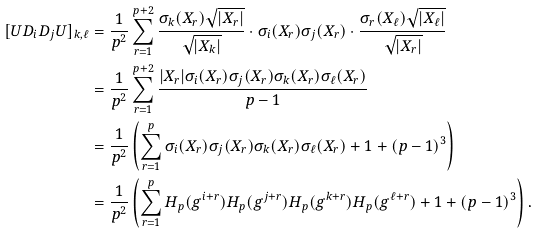Convert formula to latex. <formula><loc_0><loc_0><loc_500><loc_500>[ U D _ { i } D _ { j } U ] _ { k , \ell } & = \frac { 1 } { p ^ { 2 } } \sum _ { r = 1 } ^ { p + 2 } \frac { \sigma _ { k } ( X _ { r } ) \sqrt { | X _ { r } | } } { \sqrt { | X _ { k } | } } \cdot \sigma _ { i } ( X _ { r } ) \sigma _ { j } ( X _ { r } ) \cdot \frac { \sigma _ { r } ( X _ { \ell } ) \sqrt { | X _ { \ell } | } } { \sqrt { | X _ { r } | } } \\ & = \frac { 1 } { p ^ { 2 } } \sum _ { r = 1 } ^ { p + 2 } \frac { | X _ { r } | \sigma _ { i } ( X _ { r } ) \sigma _ { j } ( X _ { r } ) \sigma _ { k } ( X _ { r } ) \sigma _ { \ell } ( X _ { r } ) } { p - 1 } \\ & = \frac { 1 } { p ^ { 2 } } \left ( \sum _ { r = 1 } ^ { p } \sigma _ { i } ( X _ { r } ) \sigma _ { j } ( X _ { r } ) \sigma _ { k } ( X _ { r } ) \sigma _ { \ell } ( X _ { r } ) + 1 + ( p - 1 ) ^ { 3 } \right ) \\ & = \frac { 1 } { p ^ { 2 } } \left ( \sum _ { r = 1 } ^ { p } H _ { p } ( g ^ { i + r } ) H _ { p } ( g ^ { j + r } ) H _ { p } ( g ^ { k + r } ) H _ { p } ( g ^ { \ell + r } ) + 1 + ( p - 1 ) ^ { 3 } \right ) .</formula> 